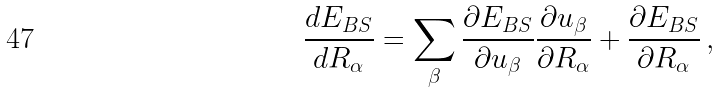Convert formula to latex. <formula><loc_0><loc_0><loc_500><loc_500>\frac { d E _ { B S } } { d R _ { \alpha } } = \sum _ { \beta } \frac { \partial E _ { B S } } { \partial u _ { \beta } } \frac { \partial u _ { \beta } } { \partial R _ { \alpha } } + \frac { \partial E _ { B S } } { \partial R _ { \alpha } } \, ,</formula> 